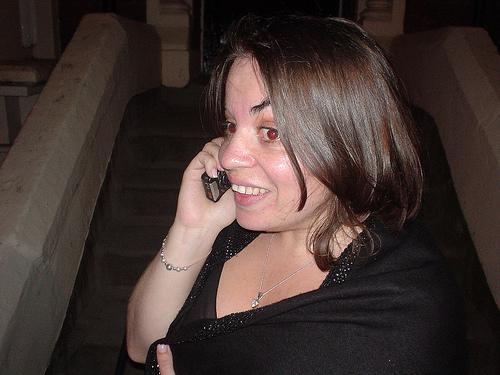Question: when is this scene taking place?
Choices:
A. At dawn.
B. At dusk.
C. Night time.
D. In the morning.
Answer with the letter. Answer: C Question: what is the person holding in her hand?
Choices:
A. Purse.
B. Book.
C. Map.
D. Cellular phone.
Answer with the letter. Answer: D Question: how long is the person's hair?
Choices:
A. Cropped.
B. Waist length.
C. Shoulder length.
D. One inch.
Answer with the letter. Answer: C Question: what structure is the person standing in front of?
Choices:
A. A fountain.
B. A museum.
C. Stairs.
D. A sign.
Answer with the letter. Answer: C Question: what garment is the person wearing around their shoulders?
Choices:
A. A sweater.
B. Shawl.
C. A jacket.
D. A scarf.
Answer with the letter. Answer: B Question: what color is the person's hair?
Choices:
A. Blonde.
B. Black.
C. Brown.
D. Grey.
Answer with the letter. Answer: C 